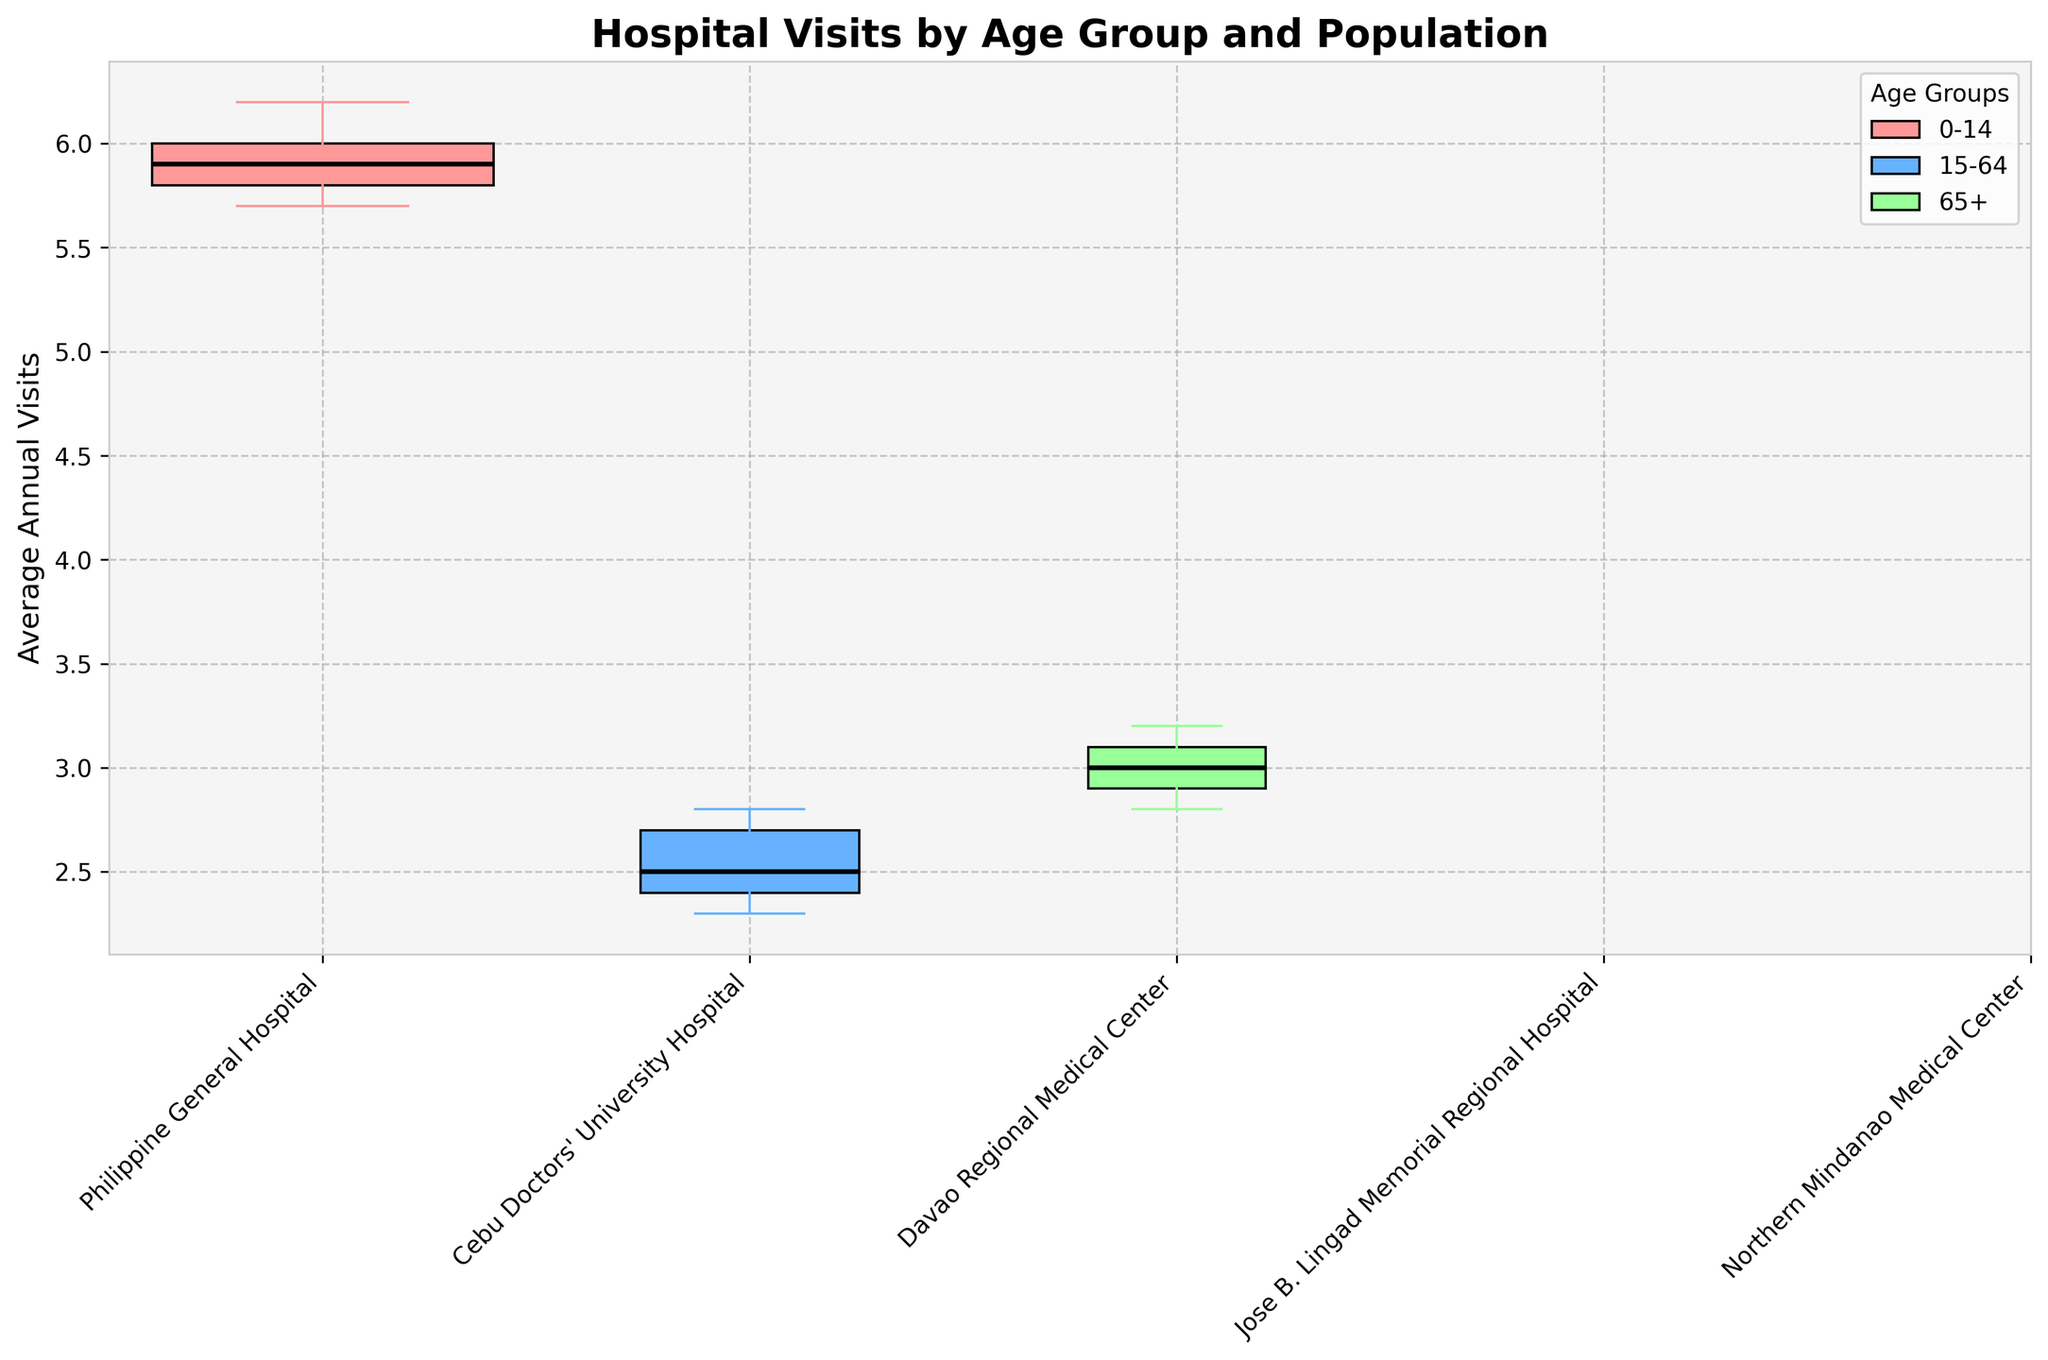What is the title of the figure? Look for the text at the top of the figure to find the title. The title is usually in larger, bold font.
Answer: Hospital Visits by Age Group and Population How many hospitals are displayed in the figure? Count the unique entries on the x-axis, where the hospital names are listed.
Answer: 5 Which age group shows the highest average annual visits at Philippine General Hospital? Identify the corresponding box for each age group and compare the median lines (black lines) within each. The highest median is the highest average annual visit.
Answer: 0-14 What is the range of average annual visits for the 15-64 age group at Cebu Doctors' University Hospital? Locate the box plot for the 15-64 age group for this hospital and find the upper and lower ends of the whiskers, which indicate the range.
Answer: 2.3 Which hospital has the widest box plot width for the 0-14 age group, indicating the largest population? Find the widest box plot among those belonging to the 0-14 age group, represented by the corresponding color.
Answer: Philippine General Hospital What is the color representing the 65+ age group in the figure? Check the legend on the figure and find the color associated with the 65+ age group.
Answer: Green (#99FF99) Compare the average annual visits for the 65+ age group between Davao Regional Medical Center and Jose B. Lingad Memorial Regional Hospital. Which has more? Look at the median lines (black lines) in the box plots of the 65+ age group for both hospitals and compare their heights.
Answer: Jose B. Lingad Memorial Regional Hospital Which hospital has the lowest average annual visits for the 0-14 age group? Identify the box plot for the 0-14 age group in each hospital and find the one with the lowest median line.
Answer: Davao Regional Medical Center What is the population size (in millions) represented by the box plot for Northern Mindanao Medical Center? Refer to the width of the box plot and the information regarding population in the plot description.
Answer: 2.4 What pattern can be observed between hospital density and average annual visits for the 15-64 age group across all hospitals? Examine each box plot for the 15-64 age group and consider any visible relationship between hospital density and the height of the median lines.
Answer: Generally, higher hospital density correlates with higher average annual visits 